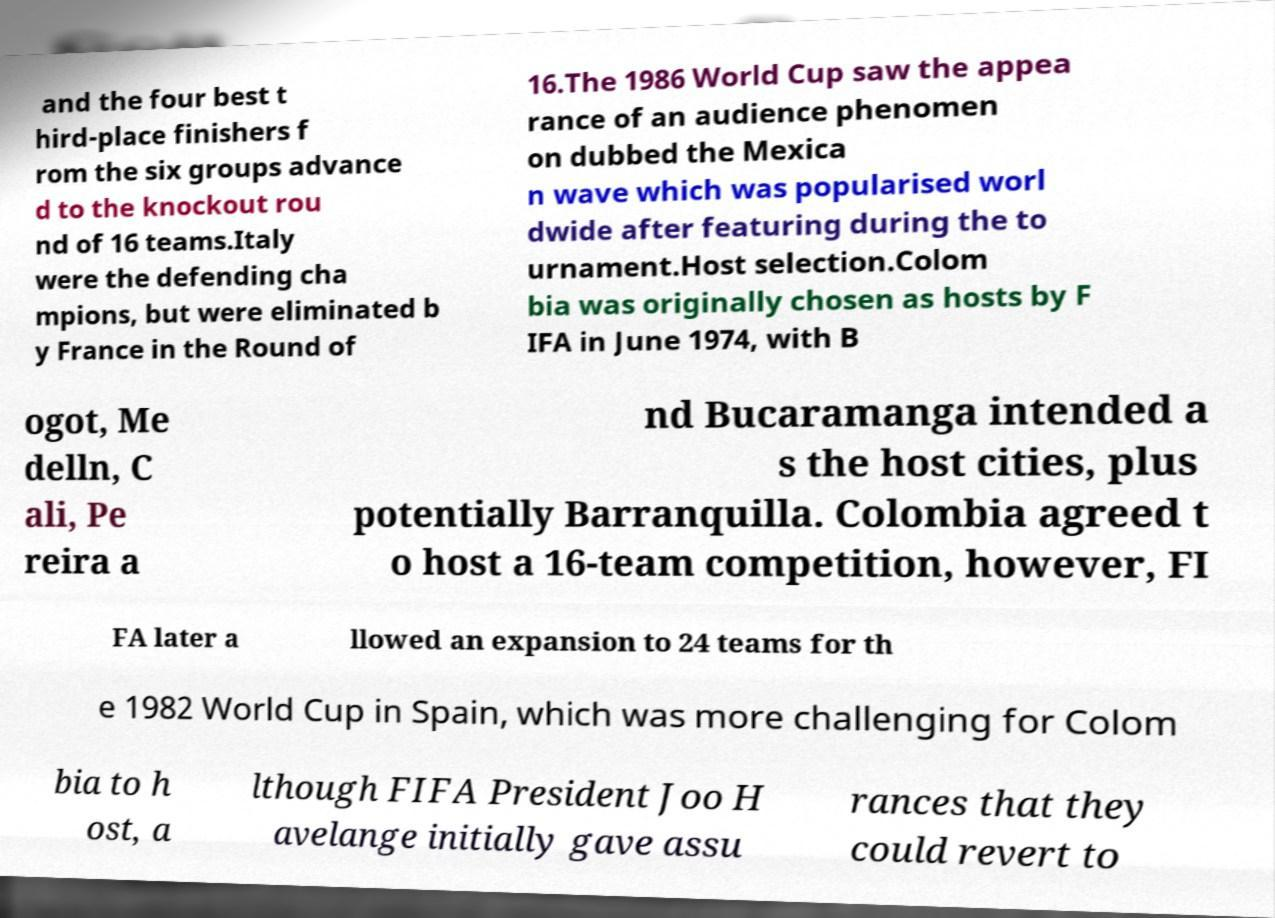Please identify and transcribe the text found in this image. and the four best t hird-place finishers f rom the six groups advance d to the knockout rou nd of 16 teams.Italy were the defending cha mpions, but were eliminated b y France in the Round of 16.The 1986 World Cup saw the appea rance of an audience phenomen on dubbed the Mexica n wave which was popularised worl dwide after featuring during the to urnament.Host selection.Colom bia was originally chosen as hosts by F IFA in June 1974, with B ogot, Me delln, C ali, Pe reira a nd Bucaramanga intended a s the host cities, plus potentially Barranquilla. Colombia agreed t o host a 16-team competition, however, FI FA later a llowed an expansion to 24 teams for th e 1982 World Cup in Spain, which was more challenging for Colom bia to h ost, a lthough FIFA President Joo H avelange initially gave assu rances that they could revert to 